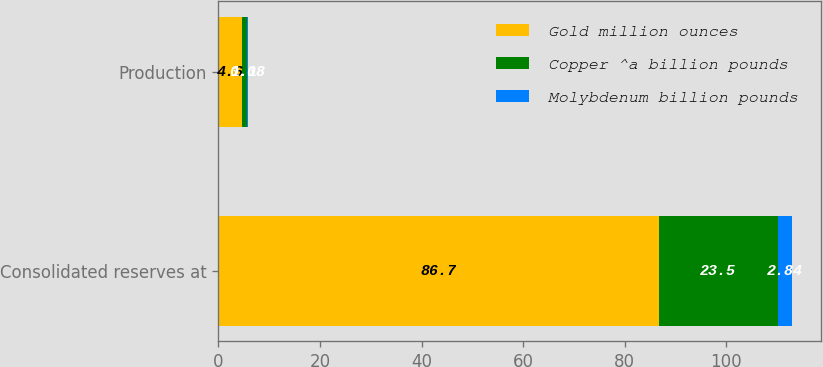Convert chart. <chart><loc_0><loc_0><loc_500><loc_500><stacked_bar_chart><ecel><fcel>Consolidated reserves at<fcel>Production<nl><fcel>Gold million ounces<fcel>86.7<fcel>4.6<nl><fcel>Copper ^a billion pounds<fcel>23.5<fcel>1.1<nl><fcel>Molybdenum billion pounds<fcel>2.84<fcel>0.08<nl></chart> 